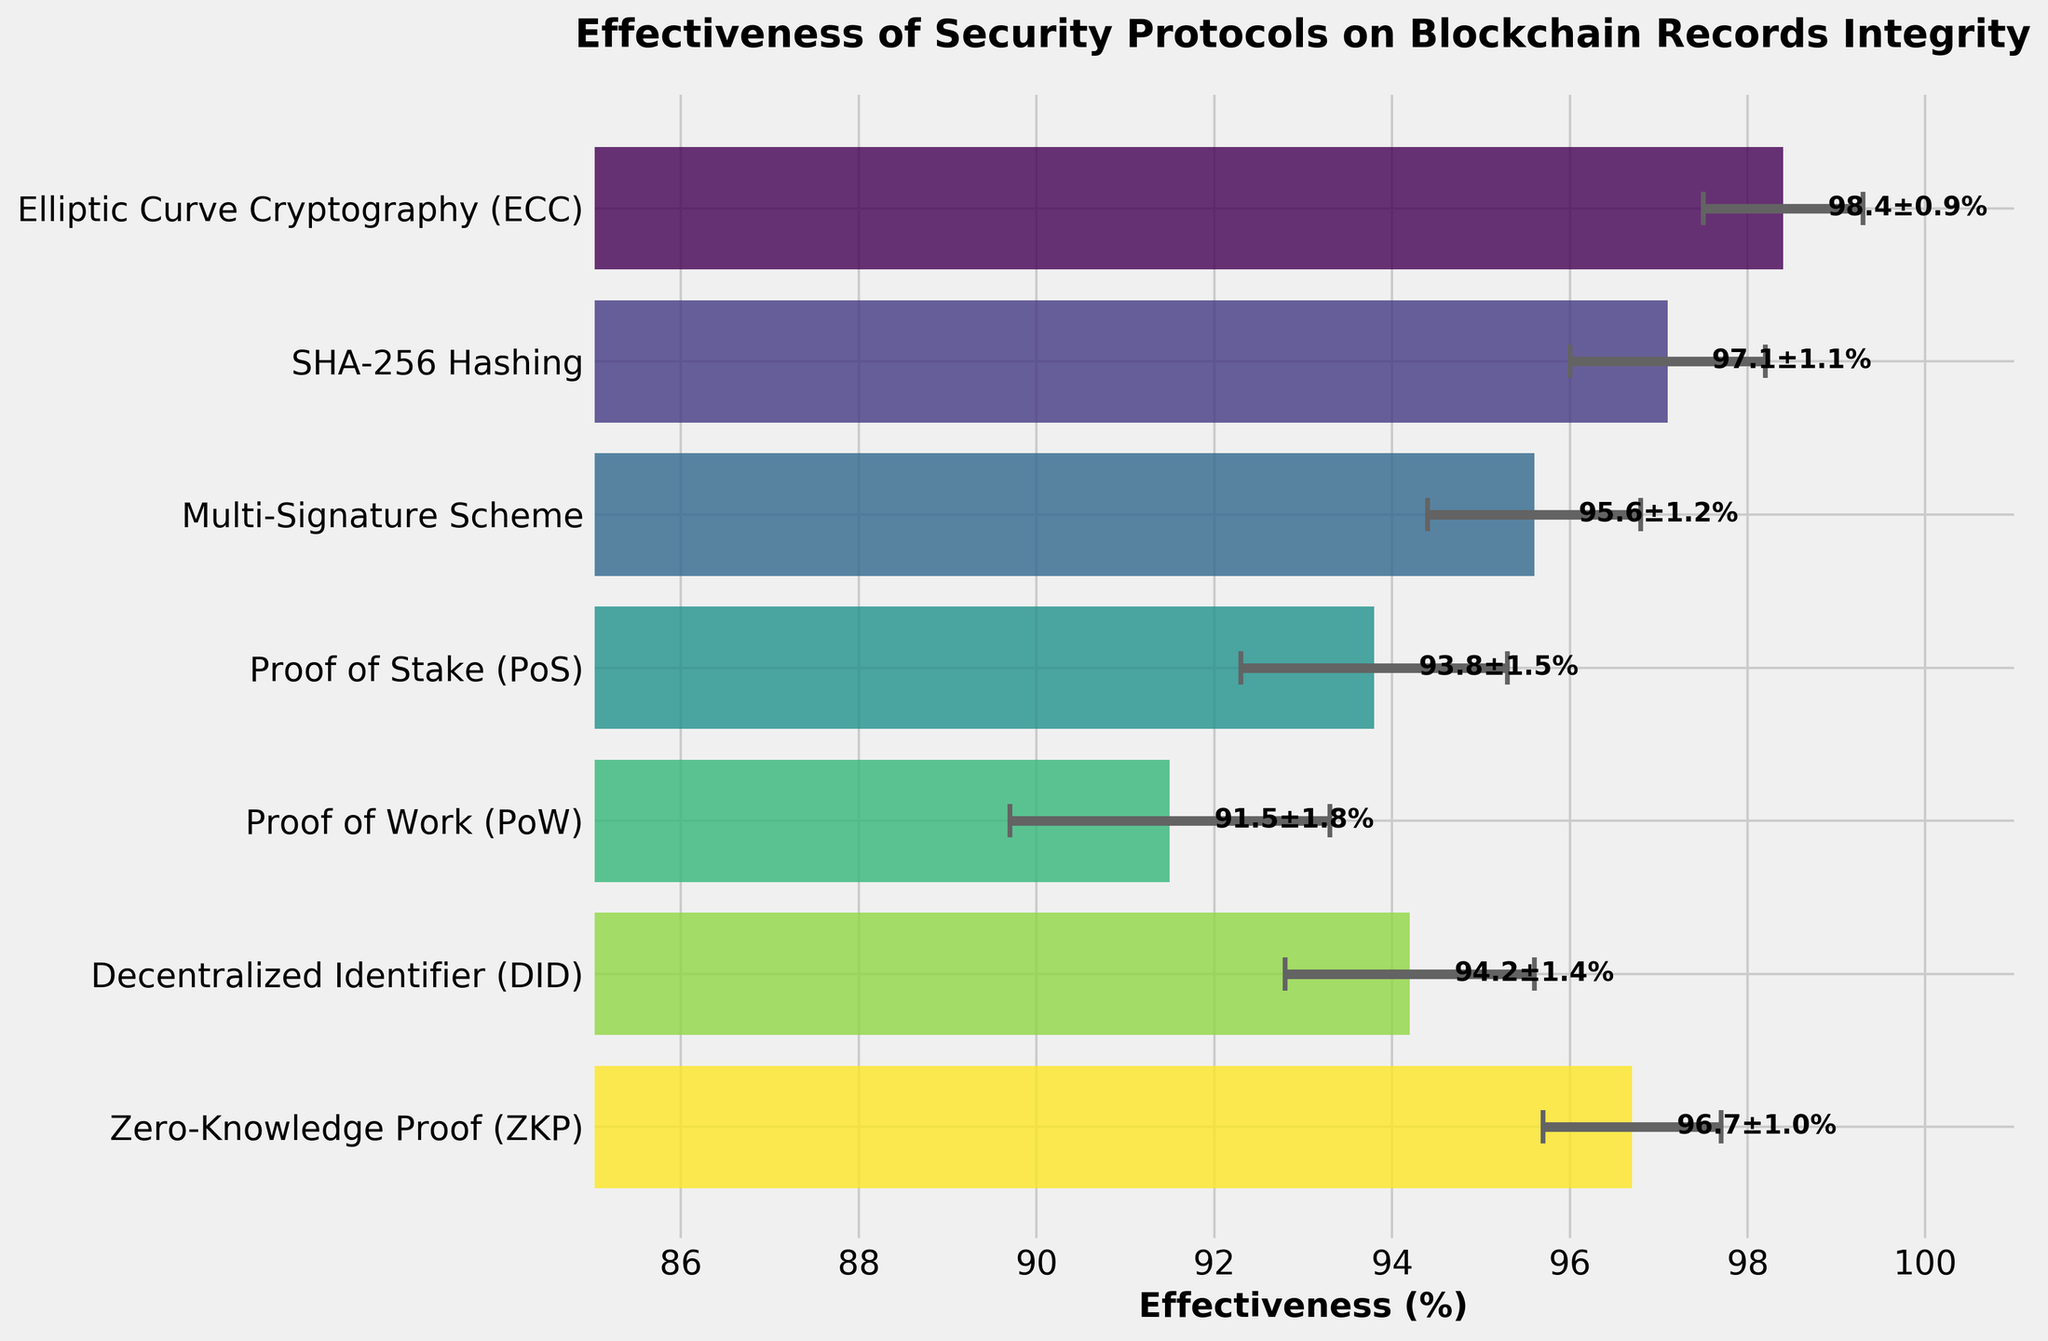What is the title of the plot? The title is displayed at the top of the plot. It clearly states, "Effectiveness of Security Protocols on Blockchain Records Integrity"
Answer: Effectiveness of Security Protocols on Blockchain Records Integrity What is the effectiveness of the Proof of Work (PoW) protocol? The effectiveness values are represented by the length of the bars on the horizontal axis. The label next to PoW shows its effectiveness.
Answer: 91.5% Which protocol has the highest effectiveness? By comparing the ends of the bars, the protocol with the longest bar has the highest effectiveness. ECC has the longest bar with an effectiveness of 98.4%.
Answer: Elliptic Curve Cryptography (ECC) How many security protocols are displayed in the plot? By counting the bars or the ticks on the vertical axis labeled with protocol names, we find a total of 7 protocols.
Answer: 7 Which protocol has the largest margin of error? The length of the error bars representing the margin of error is the longest for Proof of Work (PoW), as indicated by the widest horizontal line.
Answer: Proof of Work (PoW) What's the average effectiveness of all protocols? Sum the effectiveness values of all protocols and divide by the number of protocols. The sum is (98.4 + 97.1 + 95.6 + 93.8 + 91.5 + 94.2 + 96.7) = 667.3, and dividing by 7 gives the average.
Answer: 95.33% Which protocol has an effectiveness closest to the average value? Calculate the absolute difference between each protocol's effectiveness and the average value (95.33%) and find the smallest difference. The closest protocol is the Multi-Signature Scheme with an effectiveness of 95.6%.
Answer: Multi-Signature Scheme How does the effectiveness of Proof of Stake (PoS) compare to that of Decentralized Identifier (DID)? By looking at the lengths of the bars and their labels, PoS has an effectiveness of 93.8%, while DID has an effectiveness of 94.2%.
Answer: DID is more effective than PoS What is the effectiveness range shown in the plot? The range is determined by the highest effectiveness value (98.4% for ECC) and the lowest effectiveness value (91.5% for PoW). The range is 98.4 - 91.5.
Answer: 6.9% Is the margin of error for Zero-Knowledge Proof (ZKP) greater or less than that for SHA-256 Hashing? ZKP has a margin of error of 1.0%, while SHA-256 Hashing has a margin of error of 1.1%.
Answer: less 